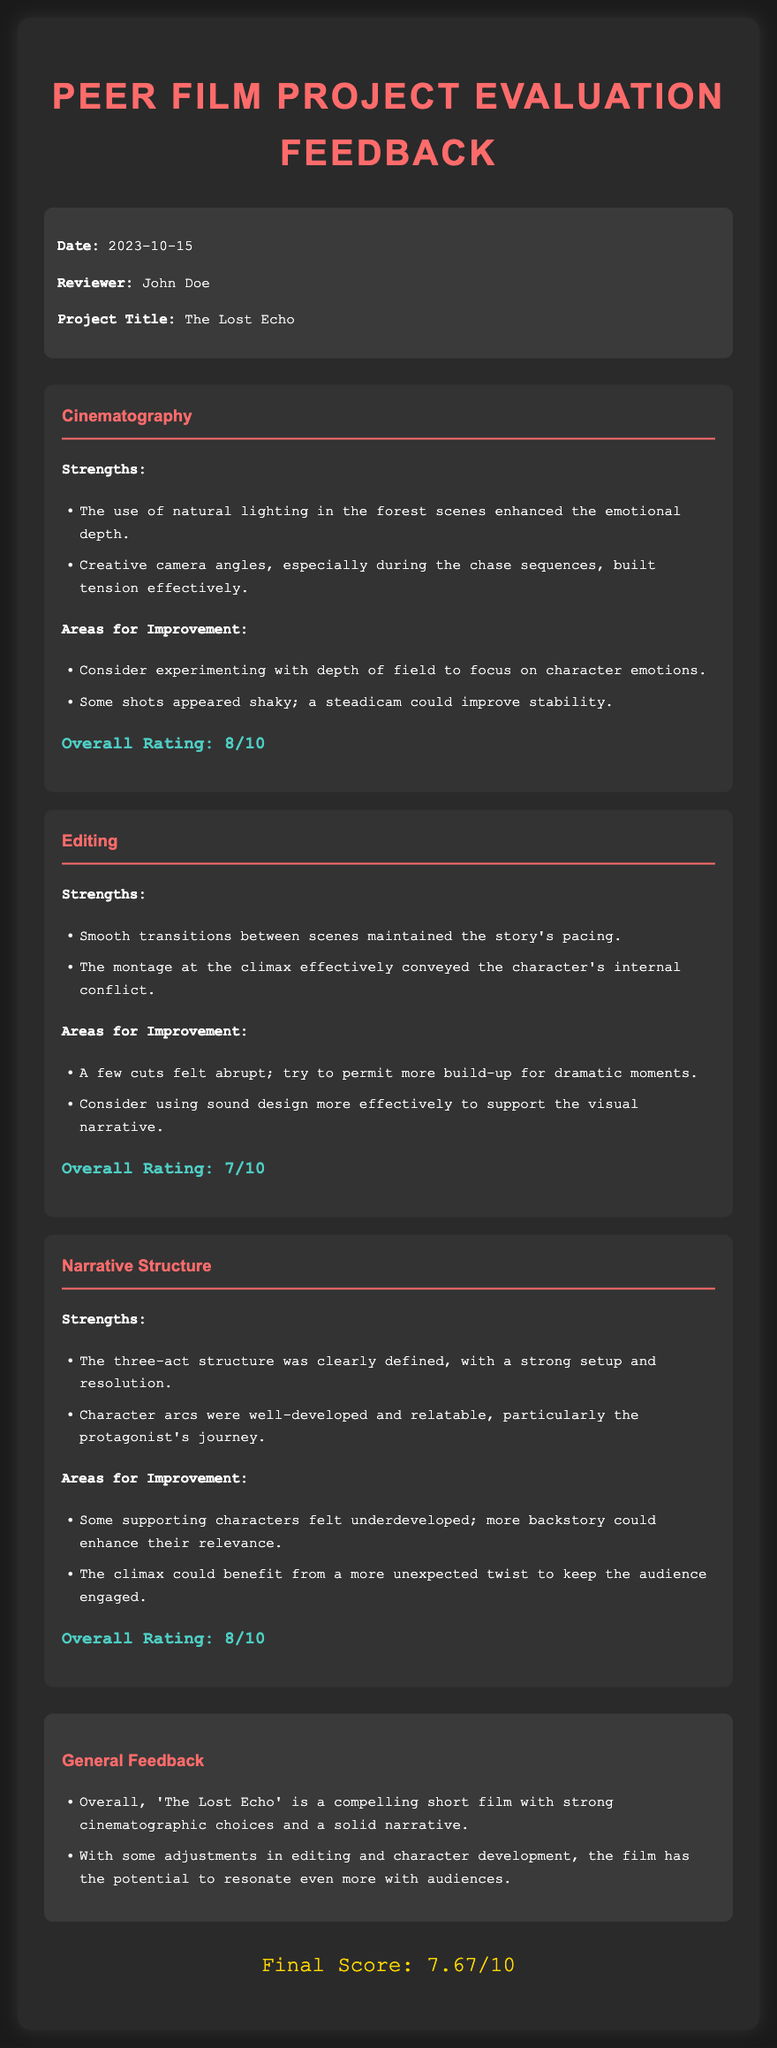What is the date of the evaluation? The date of the evaluation is mentioned in the meta-info section of the document.
Answer: 2023-10-15 Who is the reviewer? The reviewer’s name is stated in the meta-info section.
Answer: John Doe What is the title of the film project? The title of the film project can be found in the meta-info section.
Answer: The Lost Echo What is the overall rating for Cinematography? The overall rating is stated at the end of the cinematography section.
Answer: 8/10 What was identified as a strength in Editing? The strengths section lists the successful points of the editing, which is included in its category.
Answer: Smooth transitions between scenes What area for improvement is suggested for Narrative Structure? The areas for improvement are specified in the narrative structure category.
Answer: Some supporting characters felt underdeveloped What is the final score for the film? The final score is provided at the end of the document, summarizing the general evaluation.
Answer: 7.67/10 How many strengths are listed for Cinematography? The number of strengths can be counted in the respective section of the document.
Answer: 2 What is the color of the headings in the document? The color of the headings is described in the CSS style section of the document.
Answer: #ff6b6b 